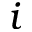Convert formula to latex. <formula><loc_0><loc_0><loc_500><loc_500>i</formula> 